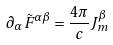<formula> <loc_0><loc_0><loc_500><loc_500>\partial _ { \alpha } \tilde { F } ^ { \alpha \beta } = \frac { 4 \pi } { c } J _ { m } ^ { \beta }</formula> 